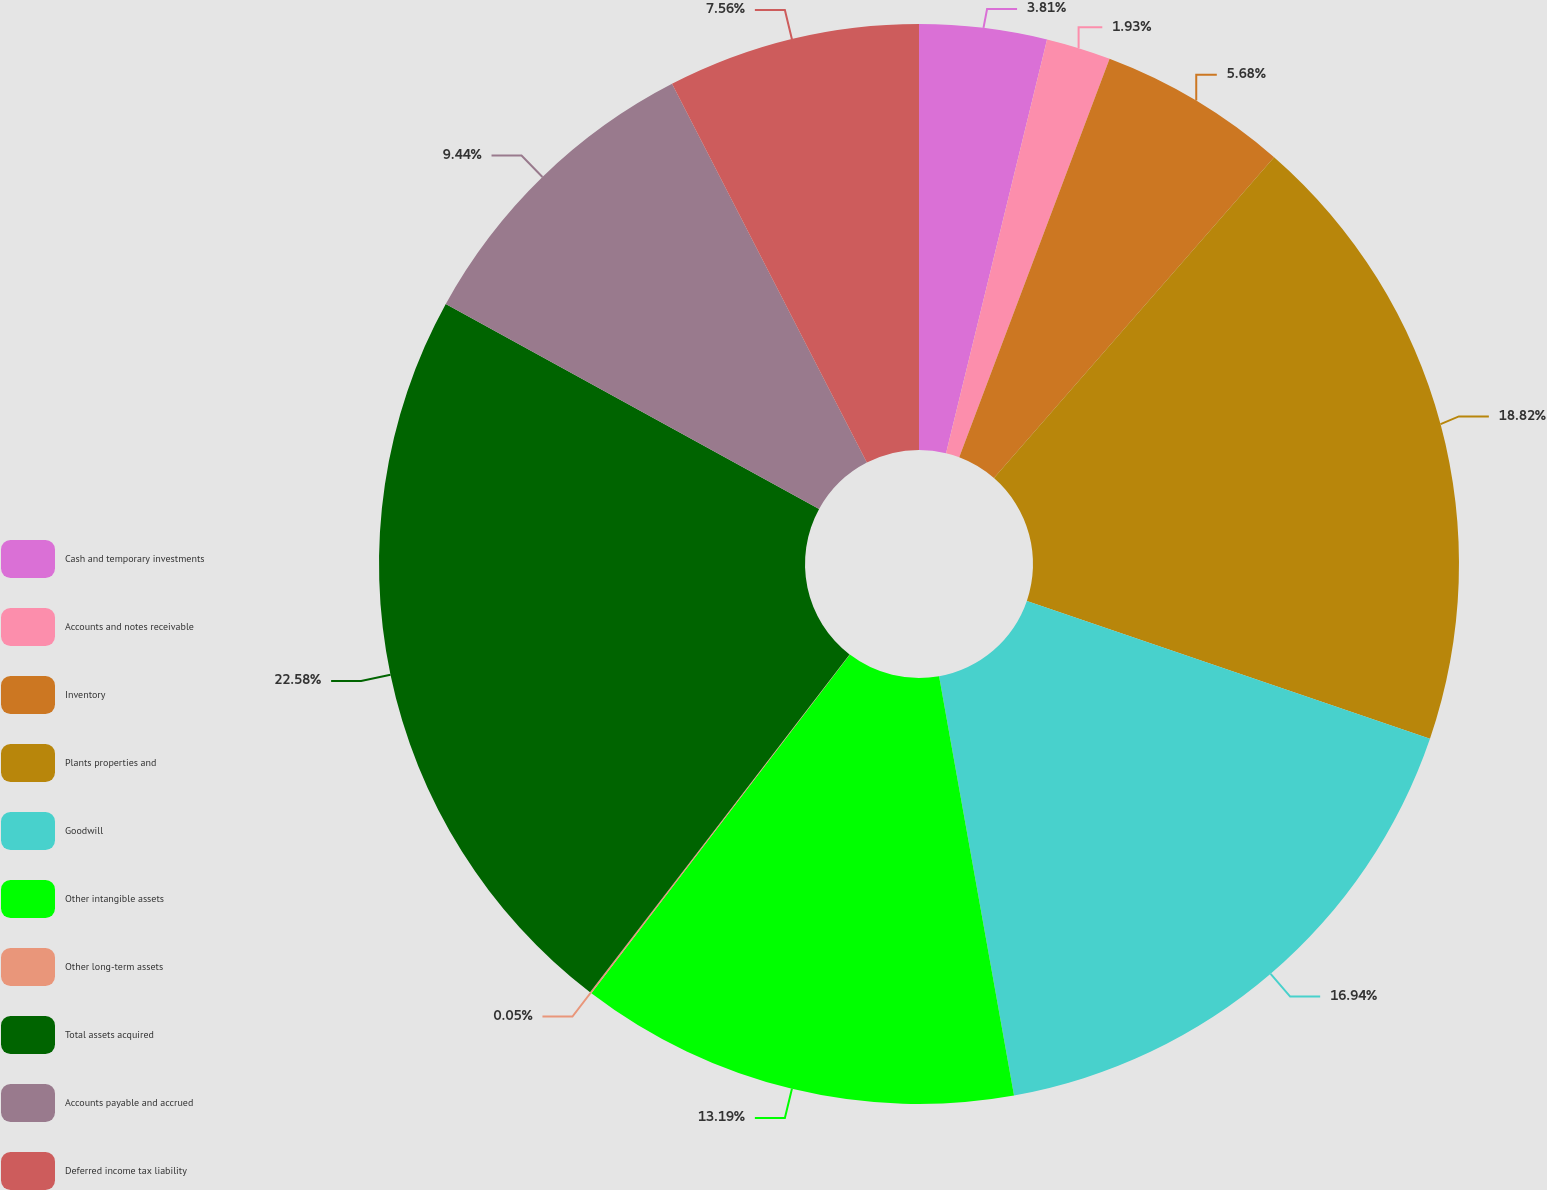Convert chart to OTSL. <chart><loc_0><loc_0><loc_500><loc_500><pie_chart><fcel>Cash and temporary investments<fcel>Accounts and notes receivable<fcel>Inventory<fcel>Plants properties and<fcel>Goodwill<fcel>Other intangible assets<fcel>Other long-term assets<fcel>Total assets acquired<fcel>Accounts payable and accrued<fcel>Deferred income tax liability<nl><fcel>3.81%<fcel>1.93%<fcel>5.68%<fcel>18.82%<fcel>16.94%<fcel>13.19%<fcel>0.05%<fcel>22.57%<fcel>9.44%<fcel>7.56%<nl></chart> 